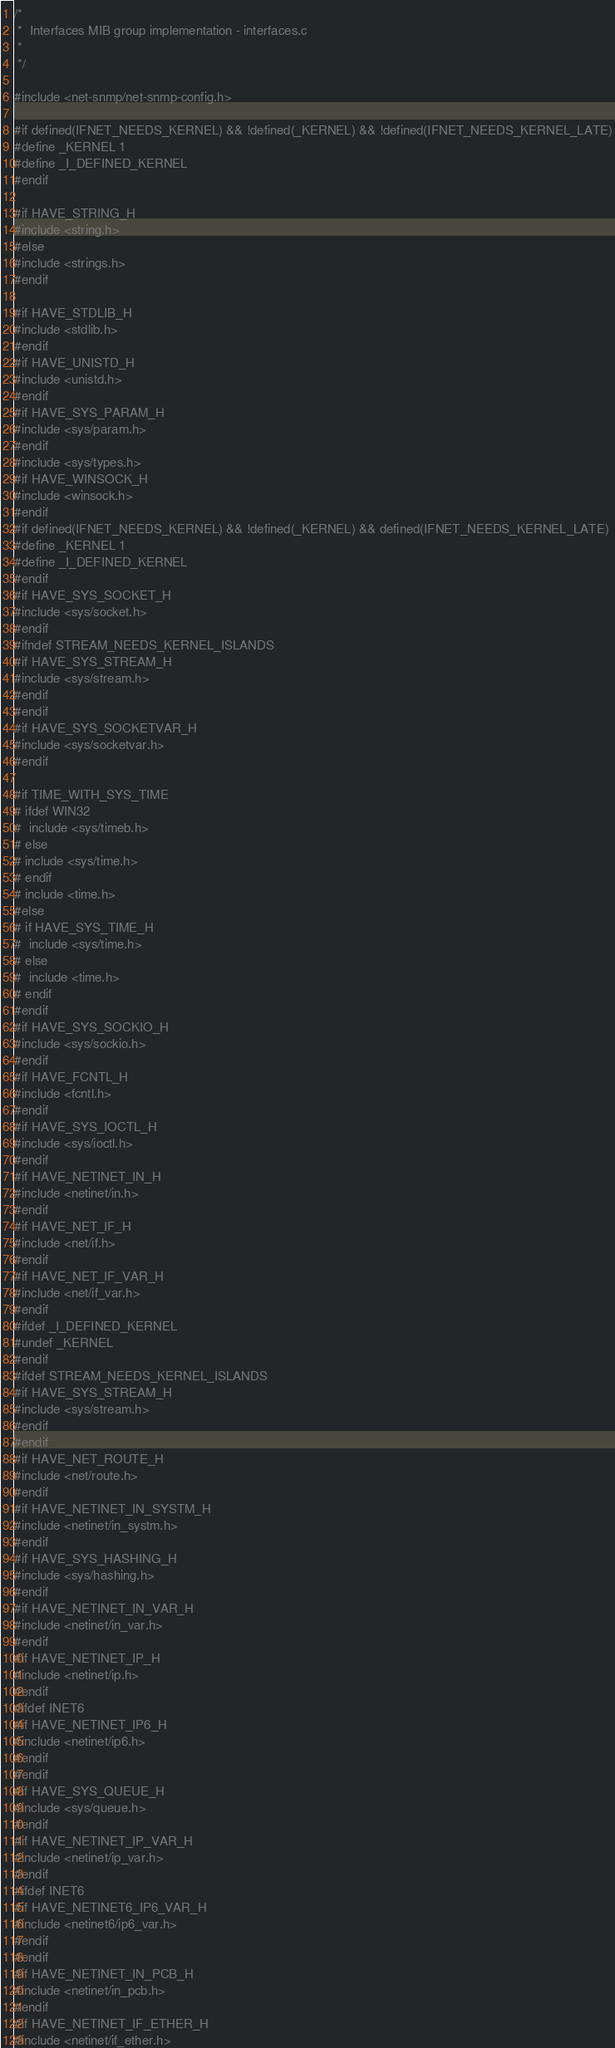<code> <loc_0><loc_0><loc_500><loc_500><_C_>/*
 *  Interfaces MIB group implementation - interfaces.c
 *
 */

#include <net-snmp/net-snmp-config.h>

#if defined(IFNET_NEEDS_KERNEL) && !defined(_KERNEL) && !defined(IFNET_NEEDS_KERNEL_LATE)
#define _KERNEL 1
#define _I_DEFINED_KERNEL
#endif

#if HAVE_STRING_H
#include <string.h>
#else
#include <strings.h>
#endif

#if HAVE_STDLIB_H
#include <stdlib.h>
#endif
#if HAVE_UNISTD_H
#include <unistd.h>
#endif
#if HAVE_SYS_PARAM_H
#include <sys/param.h>
#endif
#include <sys/types.h>
#if HAVE_WINSOCK_H
#include <winsock.h>
#endif
#if defined(IFNET_NEEDS_KERNEL) && !defined(_KERNEL) && defined(IFNET_NEEDS_KERNEL_LATE)
#define _KERNEL 1
#define _I_DEFINED_KERNEL
#endif
#if HAVE_SYS_SOCKET_H
#include <sys/socket.h>
#endif
#ifndef STREAM_NEEDS_KERNEL_ISLANDS
#if HAVE_SYS_STREAM_H
#include <sys/stream.h>
#endif
#endif
#if HAVE_SYS_SOCKETVAR_H
#include <sys/socketvar.h>
#endif

#if TIME_WITH_SYS_TIME
# ifdef WIN32
#  include <sys/timeb.h>
# else
# include <sys/time.h>
# endif
# include <time.h>
#else
# if HAVE_SYS_TIME_H
#  include <sys/time.h>
# else
#  include <time.h>
# endif
#endif
#if HAVE_SYS_SOCKIO_H
#include <sys/sockio.h>
#endif
#if HAVE_FCNTL_H
#include <fcntl.h>
#endif
#if HAVE_SYS_IOCTL_H
#include <sys/ioctl.h>
#endif
#if HAVE_NETINET_IN_H
#include <netinet/in.h>
#endif
#if HAVE_NET_IF_H
#include <net/if.h>
#endif
#if HAVE_NET_IF_VAR_H
#include <net/if_var.h>
#endif
#ifdef _I_DEFINED_KERNEL
#undef _KERNEL
#endif
#ifdef STREAM_NEEDS_KERNEL_ISLANDS
#if HAVE_SYS_STREAM_H
#include <sys/stream.h>
#endif
#endif
#if HAVE_NET_ROUTE_H
#include <net/route.h>
#endif
#if HAVE_NETINET_IN_SYSTM_H
#include <netinet/in_systm.h>
#endif
#if HAVE_SYS_HASHING_H
#include <sys/hashing.h>
#endif
#if HAVE_NETINET_IN_VAR_H
#include <netinet/in_var.h>
#endif
#if HAVE_NETINET_IP_H
#include <netinet/ip.h>
#endif
#ifdef INET6
#if HAVE_NETINET_IP6_H
#include <netinet/ip6.h>
#endif
#endif
#if HAVE_SYS_QUEUE_H
#include <sys/queue.h>
#endif
#if HAVE_NETINET_IP_VAR_H
#include <netinet/ip_var.h>
#endif
#ifdef INET6
#if HAVE_NETINET6_IP6_VAR_H
#include <netinet6/ip6_var.h>
#endif
#endif
#if HAVE_NETINET_IN_PCB_H
#include <netinet/in_pcb.h>
#endif
#if HAVE_NETINET_IF_ETHER_H
#include <netinet/if_ether.h></code> 